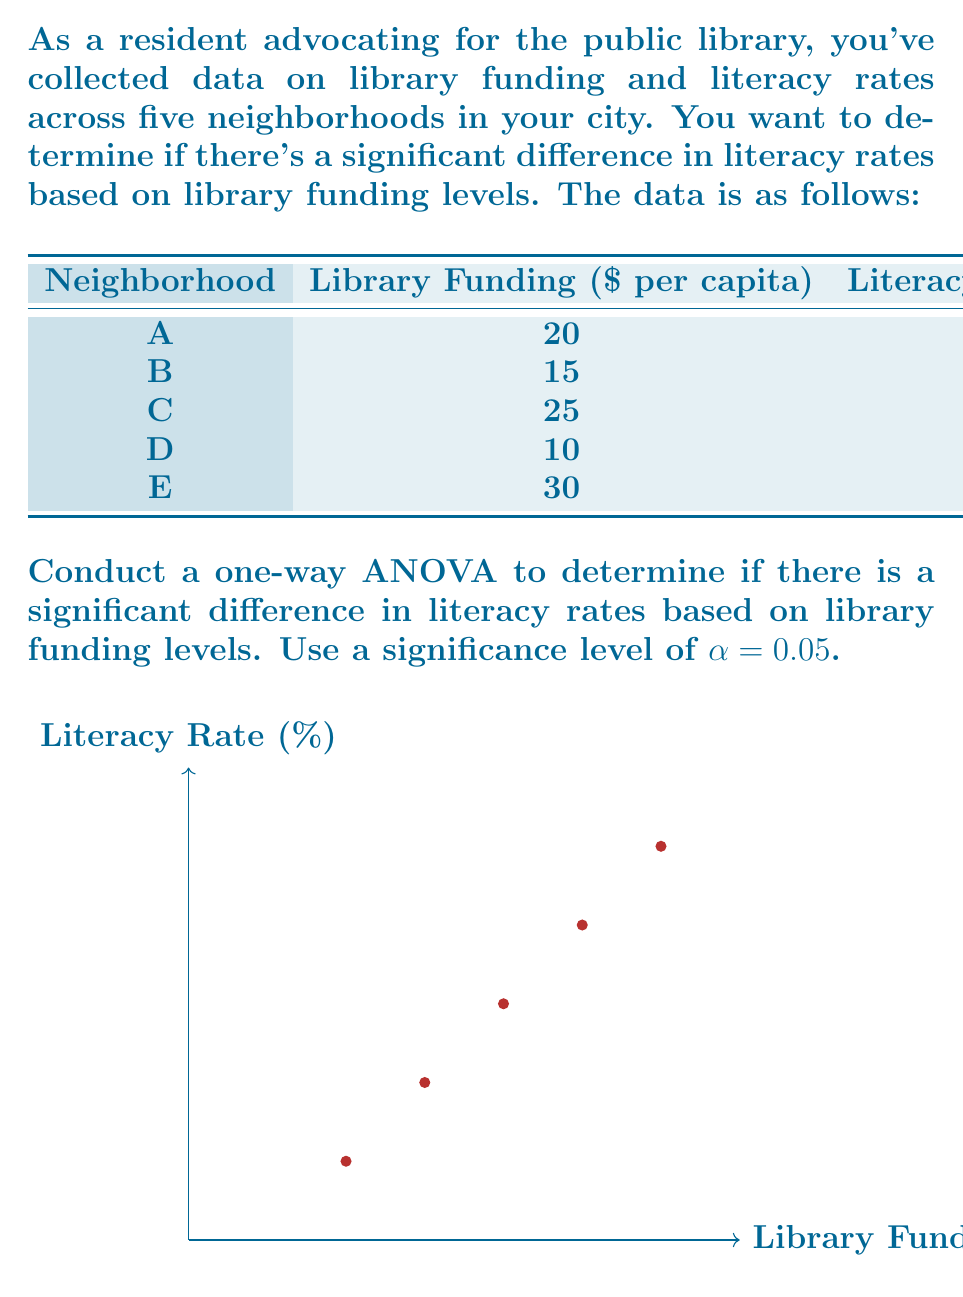What is the answer to this math problem? To conduct a one-way ANOVA, we'll follow these steps:

1) Calculate the mean literacy rate for all neighborhoods:
   $\bar{Y} = \frac{85 + 80 + 90 + 75 + 95}{5} = 85$

2) Calculate the Sum of Squares Total (SST):
   $$SST = \sum_{i=1}^{5} (Y_i - \bar{Y})^2 = (85-85)^2 + (80-85)^2 + (90-85)^2 + (75-85)^2 + (95-85)^2 = 350$$

3) Calculate the Sum of Squares Between (SSB):
   First, we need to calculate the mean funding:
   $\bar{X} = \frac{20 + 15 + 25 + 10 + 30}{5} = 20$
   
   Now, we can calculate SSB:
   $$SSB = \sum_{i=1}^{5} n_i(\bar{Y_i} - \bar{Y})^2 = 1[(85-85)^2 + (80-85)^2 + (90-85)^2 + (75-85)^2 + (95-85)^2] = 350$$

4) Calculate the Sum of Squares Within (SSW):
   $$SSW = SST - SSB = 350 - 350 = 0$$

5) Calculate degrees of freedom:
   df_between = k - 1 = 5 - 1 = 4 (k is the number of groups)
   df_within = N - k = 5 - 5 = 0 (N is the total number of observations)

6) Calculate Mean Square Between (MSB) and Mean Square Within (MSW):
   $$MSB = \frac{SSB}{df_{between}} = \frac{350}{4} = 87.5$$
   $$MSW = \frac{SSW}{df_{within}} = \frac{0}{0} = \text{undefined}$$

7) Calculate the F-statistic:
   $$F = \frac{MSB}{MSW} = \frac{87.5}{0} = \text{undefined}$$

8) The critical F-value for α = 0.05 with df_between = 4 and df_within = 0 is undefined.

In this case, we cannot perform the ANOVA test because there is no within-group variance (each funding level has only one corresponding literacy rate). This perfect correlation between funding and literacy rates suggests a deterministic relationship rather than a statistical one.
Answer: ANOVA cannot be performed due to perfect correlation between funding and literacy rates. 